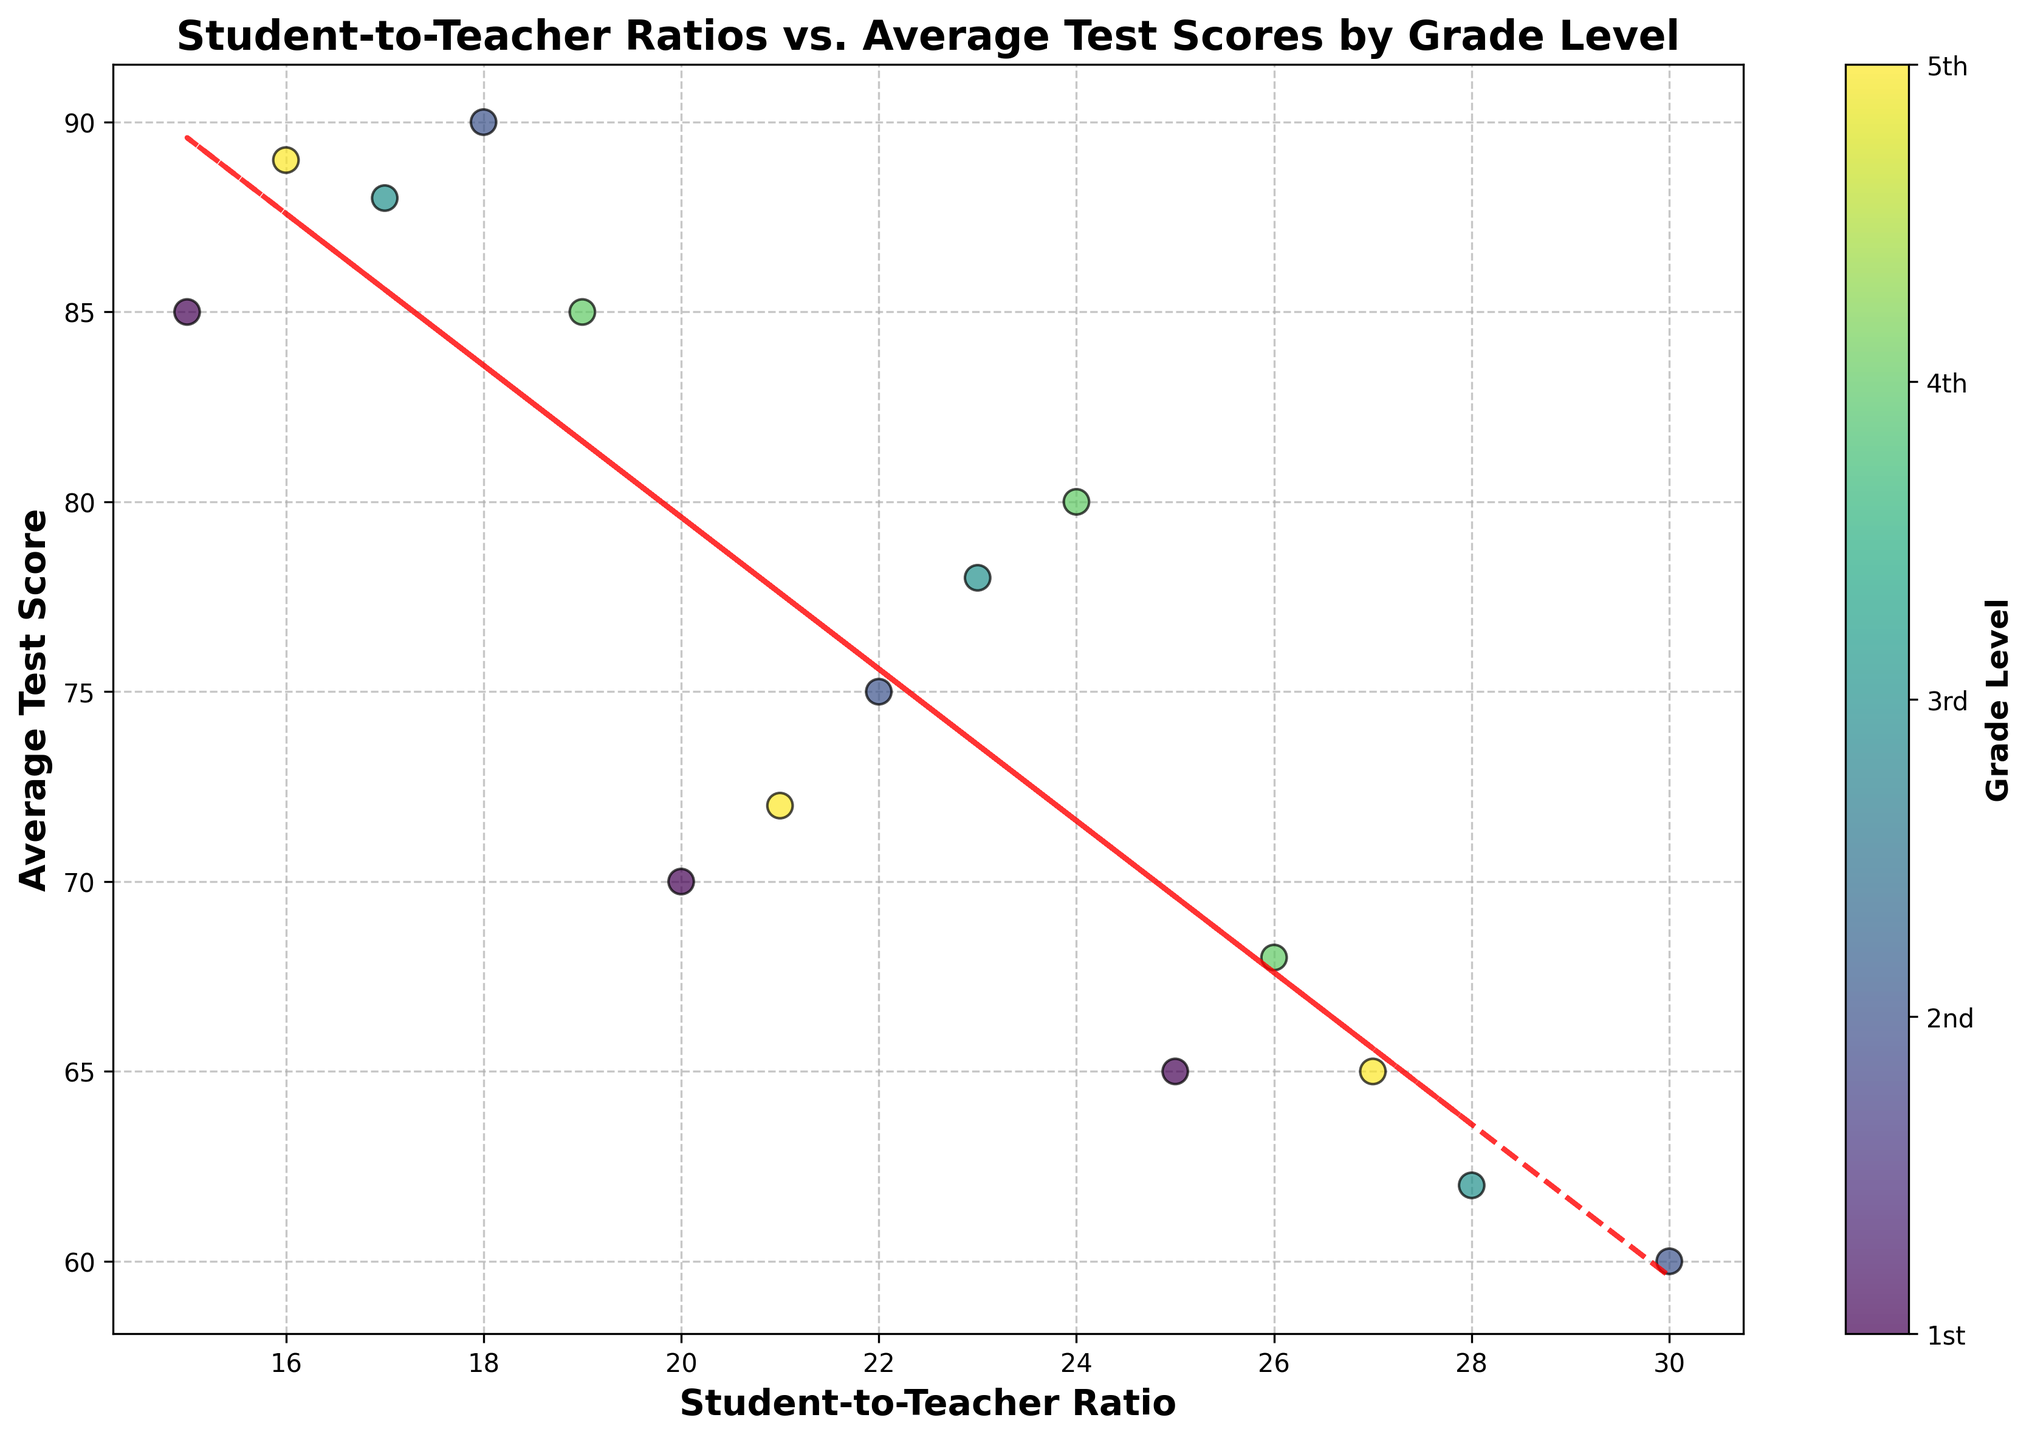What is the title of the graph? The title is displayed at the top of the graph and reads "Student-to-Teacher Ratios vs. Average Test Scores by Grade Level".
Answer: Student-to-Teacher Ratios vs. Average Test Scores by Grade Level What does the x-axis represent? The label of the x-axis indicates that it represents "Student-to-Teacher Ratio".
Answer: Student-to-Teacher Ratio What does the y-axis represent? The y-axis label indicates that it represents "Average Test Score".
Answer: Average Test Score How does the trend line relate to the data points? The red dashed trend line indicates the overall trend in the data, showing how average test scores generally change with varying student-to-teacher ratios.
Answer: It shows a negative correlation Which grade level has the highest average test scores? By looking at the data points colored by grade levels, the 5th Grade (light green) shows one of the highest average test scores.
Answer: 5th Grade Are lower student-to-teacher ratios generally associated with higher average test scores? Observing the scatter plot and the trend line, it's clear that data points with lower student-to-teacher ratios tend to have higher average test scores, indicating a negative correlation.
Answer: Yes What is the average test score for a student-to-teacher ratio of 25 in the 1st Grade? Locate the data point for 1st Grade with a ratio of 25 on the graph, and see that it corresponds to an average test score of 65.
Answer: 65 Between which two grade levels is the difference in average test scores the largest for similar student-to-teacher ratios? Compare data points with similar ratios across different grade levels on the graph. The largest difference is observed between 5th Grade and the lower grades like 1st and 2nd.
Answer: 5th Grade and 1st Grade By how much does the average test score decrease when the student-to-teacher ratio increases from 15 to 30? Observing the trend line, when the ratio increases from 15 to 30, the average test score decreases by approximately 30 points.
Answer: 30 points 